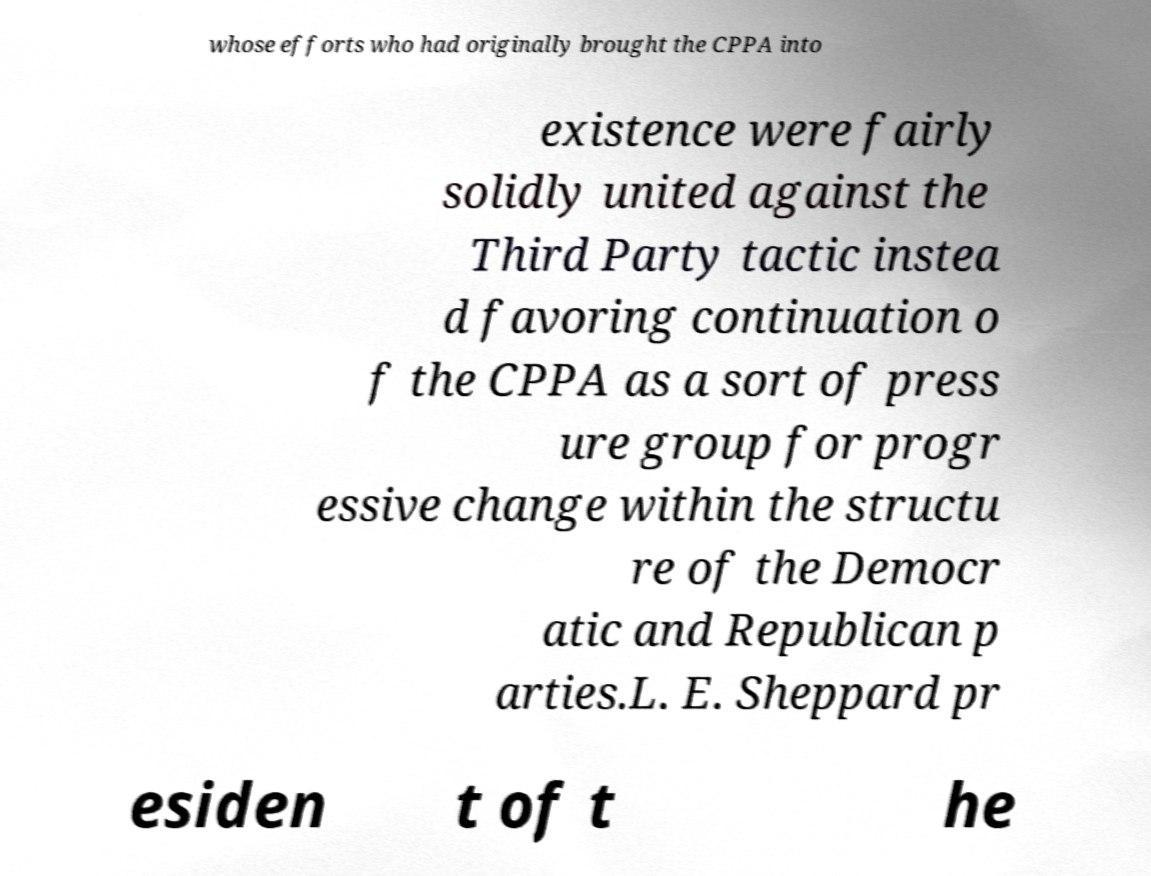Please read and relay the text visible in this image. What does it say? whose efforts who had originally brought the CPPA into existence were fairly solidly united against the Third Party tactic instea d favoring continuation o f the CPPA as a sort of press ure group for progr essive change within the structu re of the Democr atic and Republican p arties.L. E. Sheppard pr esiden t of t he 